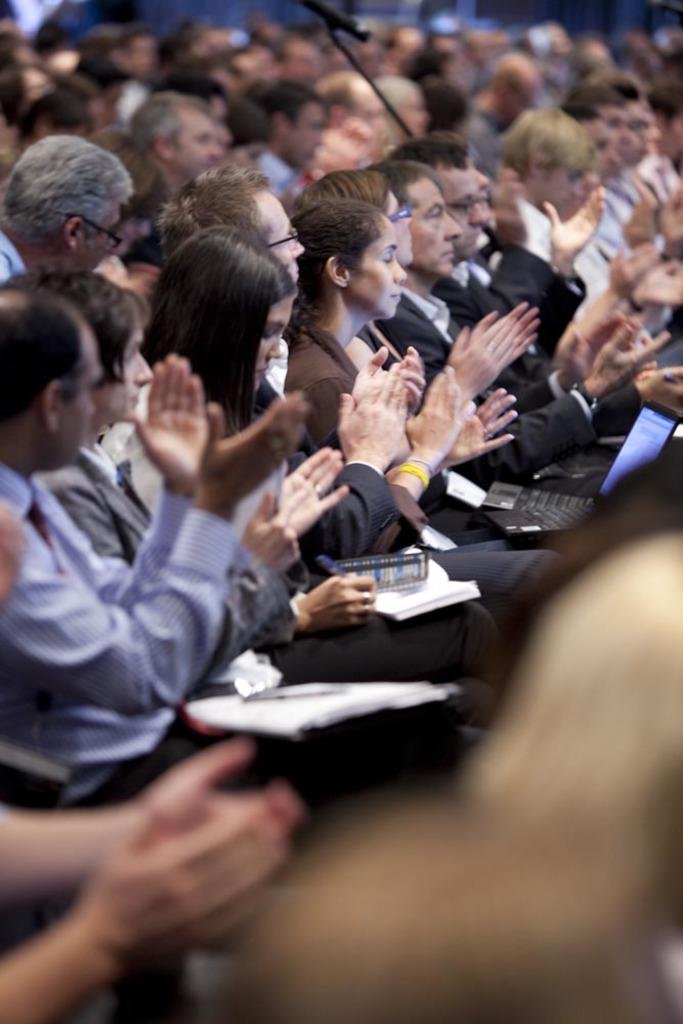What is happening in the center of the image? There is a group of people in the center of the image. What are the people doing? The people are sitting and clapping. Are any of the people using electronic devices? Yes, some of the people are holding laptops. What else are some of the people doing? Some of the people are writing. What level of balance do the people in the image need to maintain while performing the action? The provided facts do not mention any specific action or level of balance required for the people in the image. 